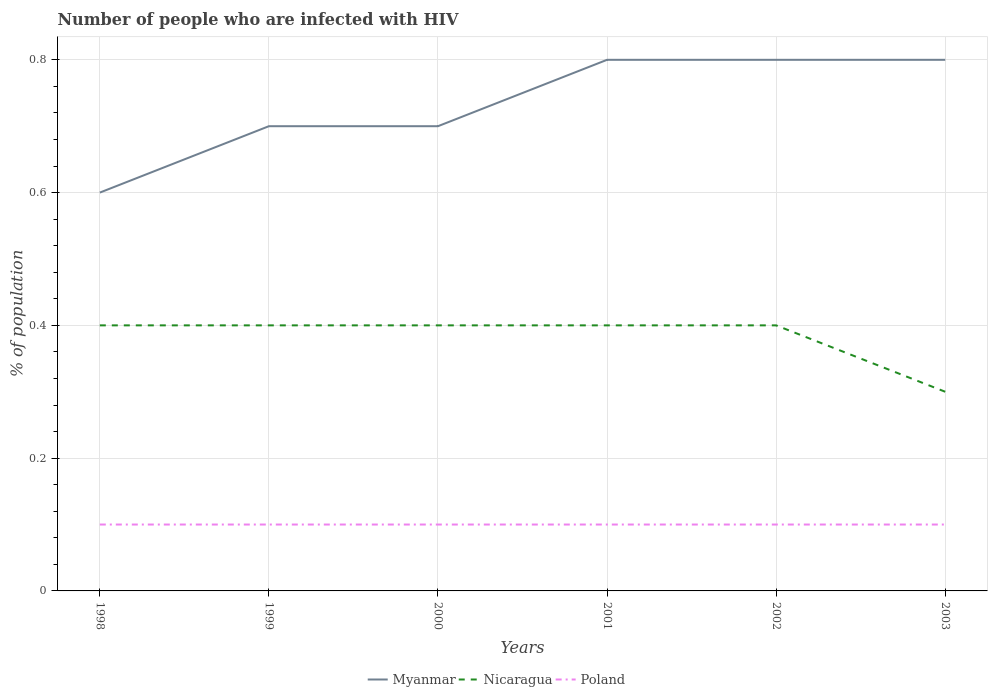How many different coloured lines are there?
Ensure brevity in your answer.  3. Does the line corresponding to Poland intersect with the line corresponding to Myanmar?
Your answer should be very brief. No. Is the number of lines equal to the number of legend labels?
Ensure brevity in your answer.  Yes. What is the total percentage of HIV infected population in in Poland in the graph?
Ensure brevity in your answer.  0. What is the difference between the highest and the second highest percentage of HIV infected population in in Nicaragua?
Offer a terse response. 0.1. What is the difference between the highest and the lowest percentage of HIV infected population in in Myanmar?
Provide a succinct answer. 3. How many years are there in the graph?
Keep it short and to the point. 6. What is the difference between two consecutive major ticks on the Y-axis?
Your answer should be very brief. 0.2. Does the graph contain any zero values?
Ensure brevity in your answer.  No. Where does the legend appear in the graph?
Keep it short and to the point. Bottom center. How are the legend labels stacked?
Keep it short and to the point. Horizontal. What is the title of the graph?
Ensure brevity in your answer.  Number of people who are infected with HIV. Does "Jamaica" appear as one of the legend labels in the graph?
Your response must be concise. No. What is the label or title of the Y-axis?
Offer a very short reply. % of population. What is the % of population in Myanmar in 1998?
Offer a terse response. 0.6. What is the % of population of Nicaragua in 1998?
Provide a succinct answer. 0.4. What is the % of population of Poland in 1998?
Make the answer very short. 0.1. What is the % of population in Myanmar in 1999?
Ensure brevity in your answer.  0.7. What is the % of population of Nicaragua in 1999?
Provide a succinct answer. 0.4. What is the % of population in Poland in 1999?
Your answer should be compact. 0.1. What is the % of population in Myanmar in 2000?
Offer a very short reply. 0.7. What is the % of population of Nicaragua in 2000?
Your answer should be very brief. 0.4. What is the % of population in Myanmar in 2001?
Your answer should be very brief. 0.8. What is the % of population in Poland in 2002?
Give a very brief answer. 0.1. What is the % of population of Myanmar in 2003?
Your answer should be very brief. 0.8. What is the % of population of Nicaragua in 2003?
Your response must be concise. 0.3. What is the % of population of Poland in 2003?
Your answer should be compact. 0.1. Across all years, what is the maximum % of population of Nicaragua?
Ensure brevity in your answer.  0.4. Across all years, what is the minimum % of population in Myanmar?
Provide a short and direct response. 0.6. Across all years, what is the minimum % of population of Nicaragua?
Your answer should be very brief. 0.3. What is the total % of population in Nicaragua in the graph?
Your response must be concise. 2.3. What is the total % of population of Poland in the graph?
Give a very brief answer. 0.6. What is the difference between the % of population in Myanmar in 1998 and that in 2001?
Your response must be concise. -0.2. What is the difference between the % of population of Nicaragua in 1998 and that in 2001?
Provide a succinct answer. 0. What is the difference between the % of population of Poland in 1998 and that in 2001?
Your response must be concise. 0. What is the difference between the % of population in Myanmar in 1998 and that in 2003?
Your answer should be very brief. -0.2. What is the difference between the % of population of Poland in 1998 and that in 2003?
Provide a succinct answer. 0. What is the difference between the % of population in Myanmar in 1999 and that in 2000?
Give a very brief answer. 0. What is the difference between the % of population of Poland in 1999 and that in 2000?
Provide a succinct answer. 0. What is the difference between the % of population of Nicaragua in 1999 and that in 2001?
Make the answer very short. 0. What is the difference between the % of population of Myanmar in 1999 and that in 2003?
Provide a short and direct response. -0.1. What is the difference between the % of population in Nicaragua in 1999 and that in 2003?
Provide a succinct answer. 0.1. What is the difference between the % of population in Poland in 1999 and that in 2003?
Your answer should be very brief. 0. What is the difference between the % of population in Nicaragua in 2000 and that in 2001?
Keep it short and to the point. 0. What is the difference between the % of population of Myanmar in 2000 and that in 2002?
Keep it short and to the point. -0.1. What is the difference between the % of population of Poland in 2000 and that in 2002?
Your answer should be compact. 0. What is the difference between the % of population of Myanmar in 2000 and that in 2003?
Your response must be concise. -0.1. What is the difference between the % of population of Nicaragua in 2000 and that in 2003?
Offer a terse response. 0.1. What is the difference between the % of population of Nicaragua in 2001 and that in 2002?
Make the answer very short. 0. What is the difference between the % of population in Poland in 2001 and that in 2002?
Your answer should be very brief. 0. What is the difference between the % of population of Myanmar in 2001 and that in 2003?
Offer a terse response. 0. What is the difference between the % of population of Myanmar in 2002 and that in 2003?
Give a very brief answer. 0. What is the difference between the % of population of Nicaragua in 2002 and that in 2003?
Provide a short and direct response. 0.1. What is the difference between the % of population in Poland in 2002 and that in 2003?
Your answer should be very brief. 0. What is the difference between the % of population of Myanmar in 1998 and the % of population of Poland in 1999?
Give a very brief answer. 0.5. What is the difference between the % of population of Nicaragua in 1998 and the % of population of Poland in 2000?
Make the answer very short. 0.3. What is the difference between the % of population in Myanmar in 1998 and the % of population in Nicaragua in 2001?
Provide a succinct answer. 0.2. What is the difference between the % of population of Myanmar in 1998 and the % of population of Poland in 2001?
Your answer should be compact. 0.5. What is the difference between the % of population in Nicaragua in 1998 and the % of population in Poland in 2001?
Give a very brief answer. 0.3. What is the difference between the % of population in Myanmar in 1998 and the % of population in Nicaragua in 2002?
Ensure brevity in your answer.  0.2. What is the difference between the % of population in Myanmar in 1998 and the % of population in Poland in 2002?
Ensure brevity in your answer.  0.5. What is the difference between the % of population of Nicaragua in 1998 and the % of population of Poland in 2002?
Provide a short and direct response. 0.3. What is the difference between the % of population of Myanmar in 1998 and the % of population of Nicaragua in 2003?
Offer a very short reply. 0.3. What is the difference between the % of population in Myanmar in 1999 and the % of population in Nicaragua in 2000?
Give a very brief answer. 0.3. What is the difference between the % of population of Myanmar in 1999 and the % of population of Poland in 2000?
Your answer should be compact. 0.6. What is the difference between the % of population in Myanmar in 1999 and the % of population in Nicaragua in 2001?
Give a very brief answer. 0.3. What is the difference between the % of population in Nicaragua in 1999 and the % of population in Poland in 2001?
Provide a short and direct response. 0.3. What is the difference between the % of population in Myanmar in 1999 and the % of population in Poland in 2002?
Your answer should be very brief. 0.6. What is the difference between the % of population in Myanmar in 1999 and the % of population in Poland in 2003?
Offer a very short reply. 0.6. What is the difference between the % of population of Nicaragua in 1999 and the % of population of Poland in 2003?
Ensure brevity in your answer.  0.3. What is the difference between the % of population in Myanmar in 2000 and the % of population in Nicaragua in 2001?
Offer a very short reply. 0.3. What is the difference between the % of population in Myanmar in 2000 and the % of population in Nicaragua in 2002?
Your answer should be very brief. 0.3. What is the difference between the % of population of Myanmar in 2000 and the % of population of Poland in 2002?
Ensure brevity in your answer.  0.6. What is the difference between the % of population of Nicaragua in 2000 and the % of population of Poland in 2002?
Your response must be concise. 0.3. What is the difference between the % of population in Myanmar in 2000 and the % of population in Poland in 2003?
Keep it short and to the point. 0.6. What is the difference between the % of population of Nicaragua in 2000 and the % of population of Poland in 2003?
Your response must be concise. 0.3. What is the difference between the % of population in Myanmar in 2001 and the % of population in Nicaragua in 2002?
Your response must be concise. 0.4. What is the difference between the % of population in Myanmar in 2001 and the % of population in Nicaragua in 2003?
Make the answer very short. 0.5. What is the difference between the % of population of Myanmar in 2002 and the % of population of Poland in 2003?
Offer a very short reply. 0.7. What is the difference between the % of population in Nicaragua in 2002 and the % of population in Poland in 2003?
Keep it short and to the point. 0.3. What is the average % of population of Myanmar per year?
Keep it short and to the point. 0.73. What is the average % of population in Nicaragua per year?
Make the answer very short. 0.38. In the year 1998, what is the difference between the % of population of Myanmar and % of population of Poland?
Your answer should be compact. 0.5. In the year 1999, what is the difference between the % of population of Myanmar and % of population of Nicaragua?
Offer a very short reply. 0.3. In the year 1999, what is the difference between the % of population of Nicaragua and % of population of Poland?
Your response must be concise. 0.3. In the year 2000, what is the difference between the % of population of Myanmar and % of population of Poland?
Make the answer very short. 0.6. In the year 2000, what is the difference between the % of population in Nicaragua and % of population in Poland?
Provide a short and direct response. 0.3. In the year 2001, what is the difference between the % of population in Myanmar and % of population in Nicaragua?
Provide a short and direct response. 0.4. In the year 2001, what is the difference between the % of population of Myanmar and % of population of Poland?
Offer a very short reply. 0.7. In the year 2001, what is the difference between the % of population of Nicaragua and % of population of Poland?
Offer a very short reply. 0.3. In the year 2002, what is the difference between the % of population in Myanmar and % of population in Poland?
Your response must be concise. 0.7. In the year 2002, what is the difference between the % of population of Nicaragua and % of population of Poland?
Your answer should be very brief. 0.3. In the year 2003, what is the difference between the % of population of Myanmar and % of population of Poland?
Provide a short and direct response. 0.7. What is the ratio of the % of population in Nicaragua in 1998 to that in 1999?
Offer a terse response. 1. What is the ratio of the % of population of Myanmar in 1998 to that in 2000?
Keep it short and to the point. 0.86. What is the ratio of the % of population of Myanmar in 1998 to that in 2003?
Offer a very short reply. 0.75. What is the ratio of the % of population of Nicaragua in 1998 to that in 2003?
Provide a short and direct response. 1.33. What is the ratio of the % of population of Poland in 1998 to that in 2003?
Provide a succinct answer. 1. What is the ratio of the % of population in Poland in 1999 to that in 2000?
Your answer should be very brief. 1. What is the ratio of the % of population of Myanmar in 1999 to that in 2002?
Your answer should be compact. 0.88. What is the ratio of the % of population in Poland in 2000 to that in 2002?
Provide a short and direct response. 1. What is the ratio of the % of population in Myanmar in 2000 to that in 2003?
Offer a very short reply. 0.88. What is the ratio of the % of population of Myanmar in 2001 to that in 2002?
Provide a short and direct response. 1. What is the ratio of the % of population in Myanmar in 2001 to that in 2003?
Offer a terse response. 1. What is the ratio of the % of population of Myanmar in 2002 to that in 2003?
Provide a succinct answer. 1. What is the ratio of the % of population in Nicaragua in 2002 to that in 2003?
Keep it short and to the point. 1.33. What is the difference between the highest and the second highest % of population in Myanmar?
Offer a very short reply. 0. What is the difference between the highest and the second highest % of population in Nicaragua?
Provide a short and direct response. 0. What is the difference between the highest and the lowest % of population in Myanmar?
Offer a very short reply. 0.2. What is the difference between the highest and the lowest % of population in Nicaragua?
Your response must be concise. 0.1. 